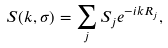<formula> <loc_0><loc_0><loc_500><loc_500>S ( { k } , \sigma ) = \sum _ { j } S _ { j } e ^ { - i { k R } _ { j } } ,</formula> 